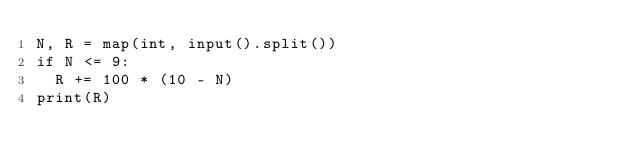<code> <loc_0><loc_0><loc_500><loc_500><_Python_>N, R = map(int, input().split())
if N <= 9:
  R += 100 * (10 - N)
print(R)</code> 